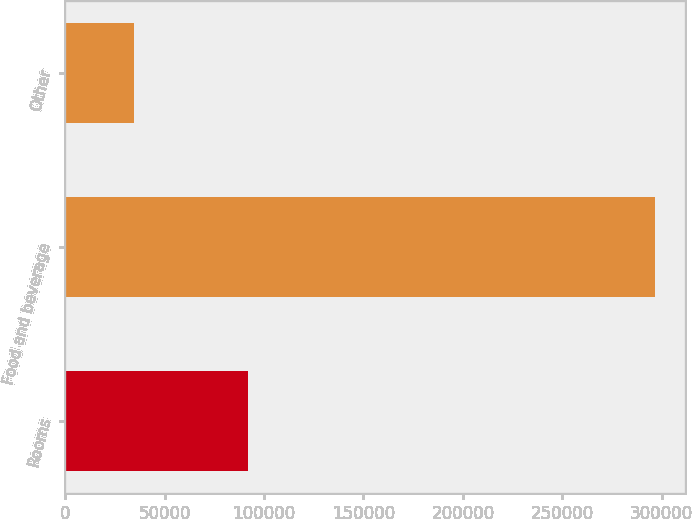Convert chart. <chart><loc_0><loc_0><loc_500><loc_500><bar_chart><fcel>Rooms<fcel>Food and beverage<fcel>Other<nl><fcel>91799<fcel>296866<fcel>34439<nl></chart> 